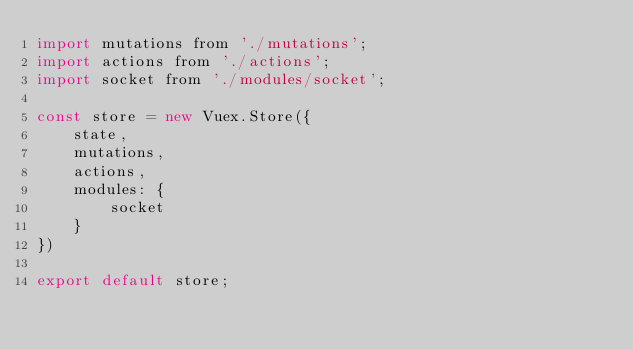Convert code to text. <code><loc_0><loc_0><loc_500><loc_500><_JavaScript_>import mutations from './mutations';
import actions from './actions';
import socket from './modules/socket';

const store = new Vuex.Store({
    state,
    mutations,
    actions,
    modules: {
        socket
    }
})

export default store;</code> 